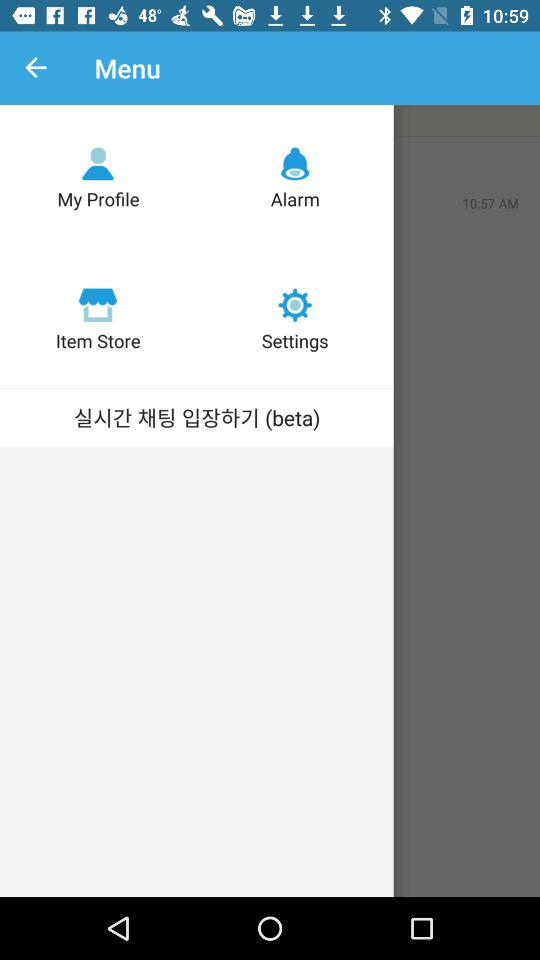How many items are in the second row?
Answer the question using a single word or phrase. 2 